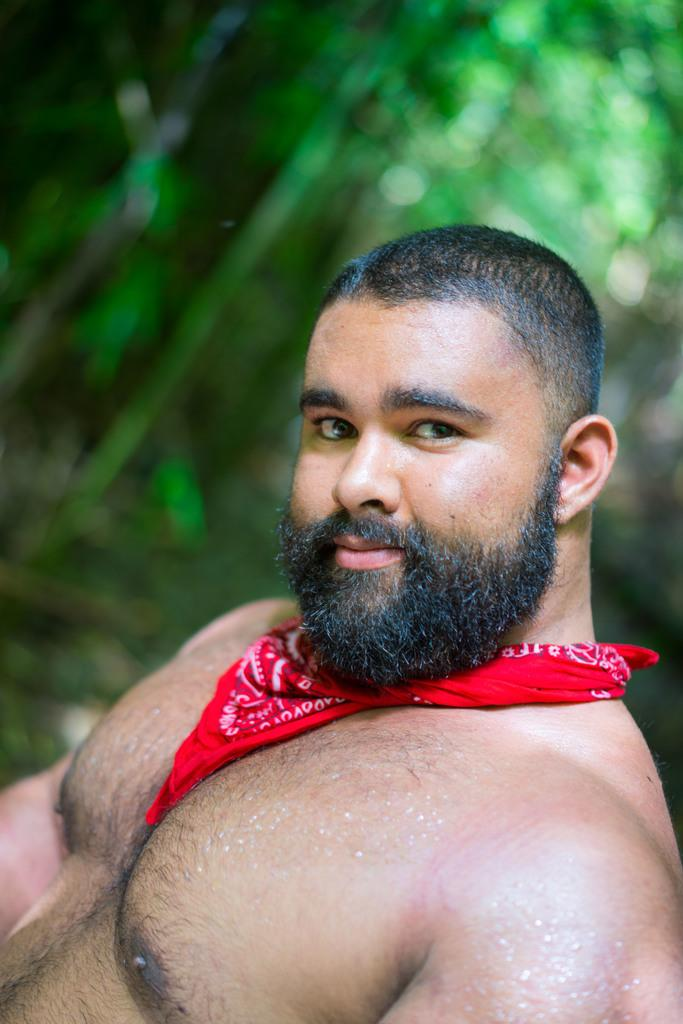Who is the main subject in the image? There is a man in the image. What is the man wearing around his neck? The man is wearing a scarf around his neck. What can be observed about the background of the image? The background of the image is green and blurred. How many frogs are sitting on the man's brother's shoulder in the image? There is no mention of a brother or frogs in the image, so this question cannot be answered definitively. 